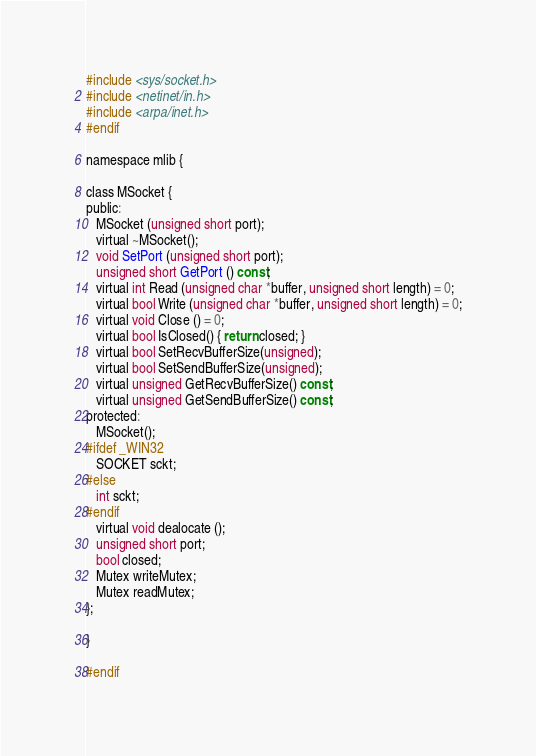<code> <loc_0><loc_0><loc_500><loc_500><_C_>#include <sys/socket.h>
#include <netinet/in.h>
#include <arpa/inet.h>
#endif

namespace mlib {

class MSocket {
public:
   MSocket (unsigned short port);
   virtual ~MSocket();
   void SetPort (unsigned short port);
   unsigned short GetPort () const;
   virtual int Read (unsigned char *buffer, unsigned short length) = 0;
   virtual bool Write (unsigned char *buffer, unsigned short length) = 0;
   virtual void Close () = 0;
   virtual bool IsClosed() { return closed; }
   virtual bool SetRecvBufferSize(unsigned);
   virtual bool SetSendBufferSize(unsigned);
   virtual unsigned GetRecvBufferSize() const;
   virtual unsigned GetSendBufferSize() const;
protected:
   MSocket();
#ifdef _WIN32
   SOCKET sckt;
#else
   int sckt;
#endif
   virtual void dealocate ();
   unsigned short port;
   bool closed;
   Mutex writeMutex;
   Mutex readMutex;
};

}

#endif
</code> 